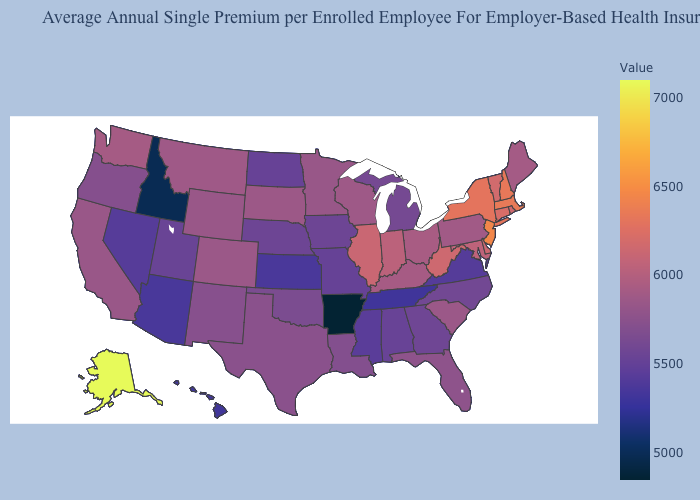Among the states that border Indiana , does Illinois have the highest value?
Concise answer only. Yes. Does West Virginia have the highest value in the South?
Give a very brief answer. Yes. Among the states that border Illinois , which have the highest value?
Answer briefly. Indiana. Does Hawaii have the lowest value in the West?
Concise answer only. No. Does Montana have a lower value than Missouri?
Answer briefly. No. Does Indiana have a lower value than Oregon?
Answer briefly. No. 